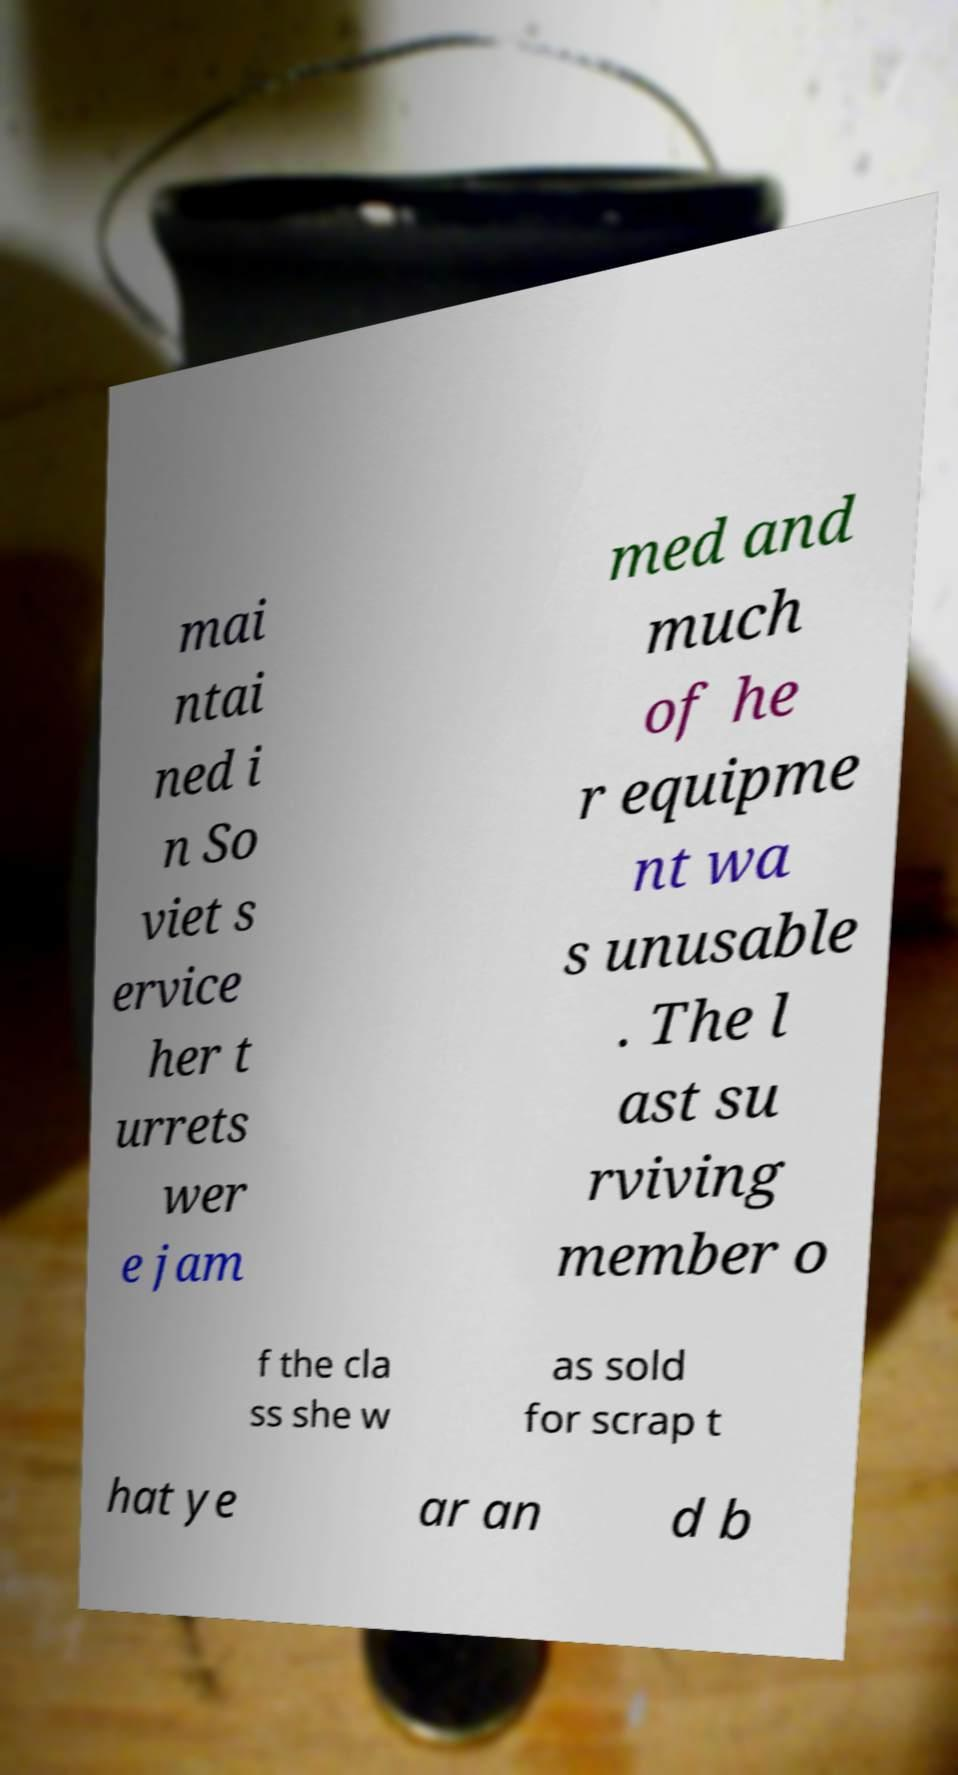I need the written content from this picture converted into text. Can you do that? mai ntai ned i n So viet s ervice her t urrets wer e jam med and much of he r equipme nt wa s unusable . The l ast su rviving member o f the cla ss she w as sold for scrap t hat ye ar an d b 